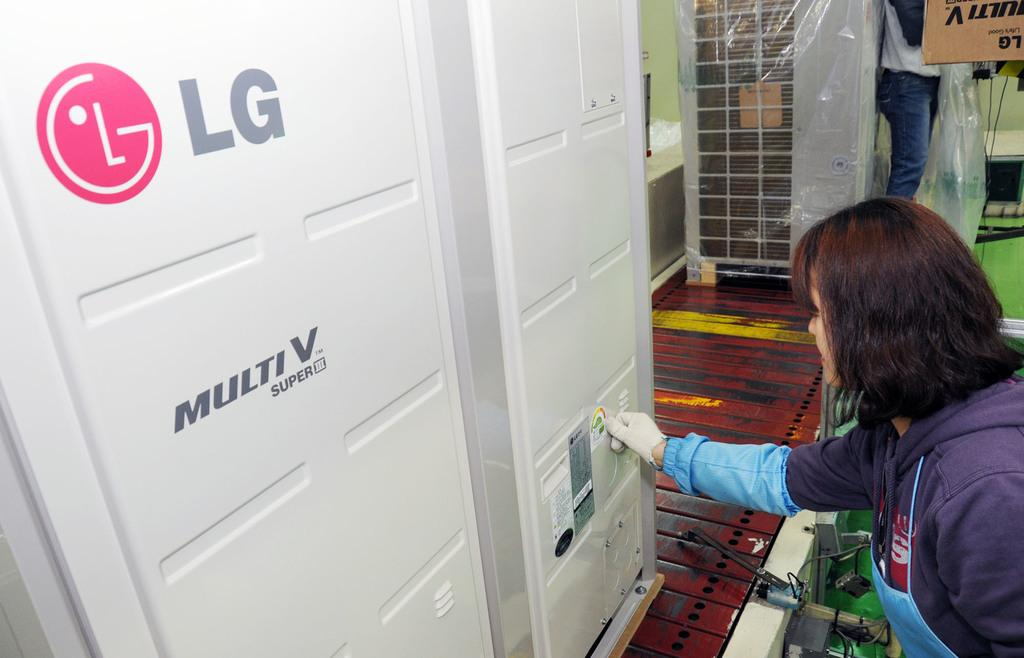<image>
Present a compact description of the photo's key features. A woman is next to a machine, which bears the letters "LG" 